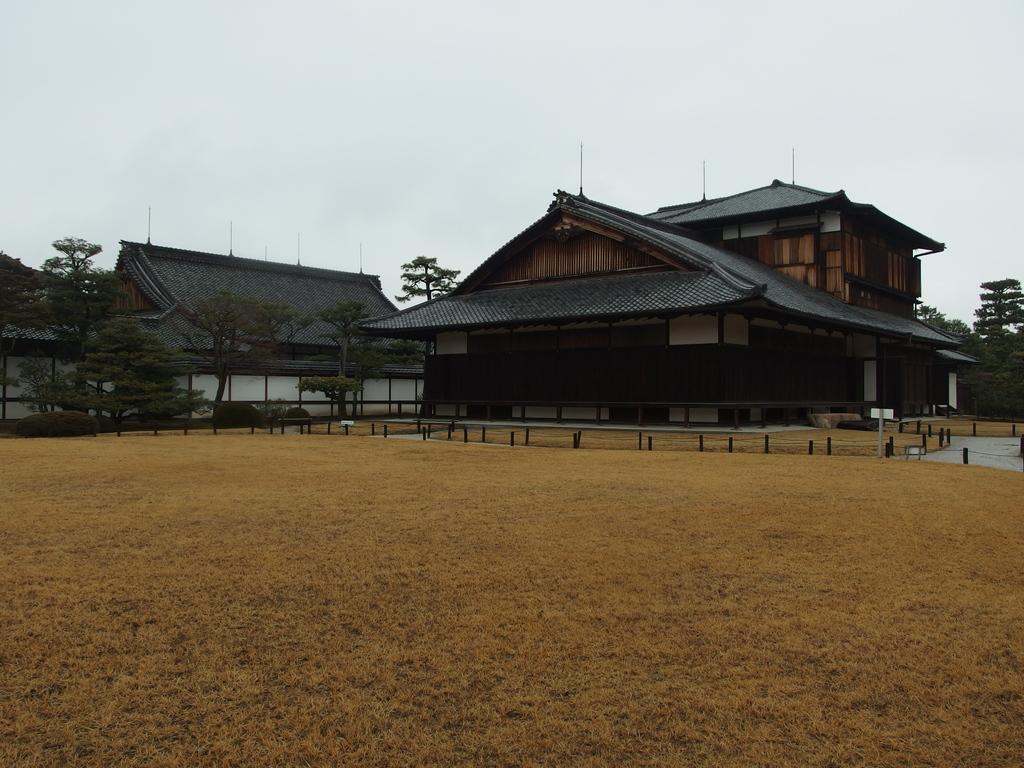Could you give a brief overview of what you see in this image? In this image there are houses. In front of the house there is the ground. Behind the houses there are trees. At the top there is the sky. 